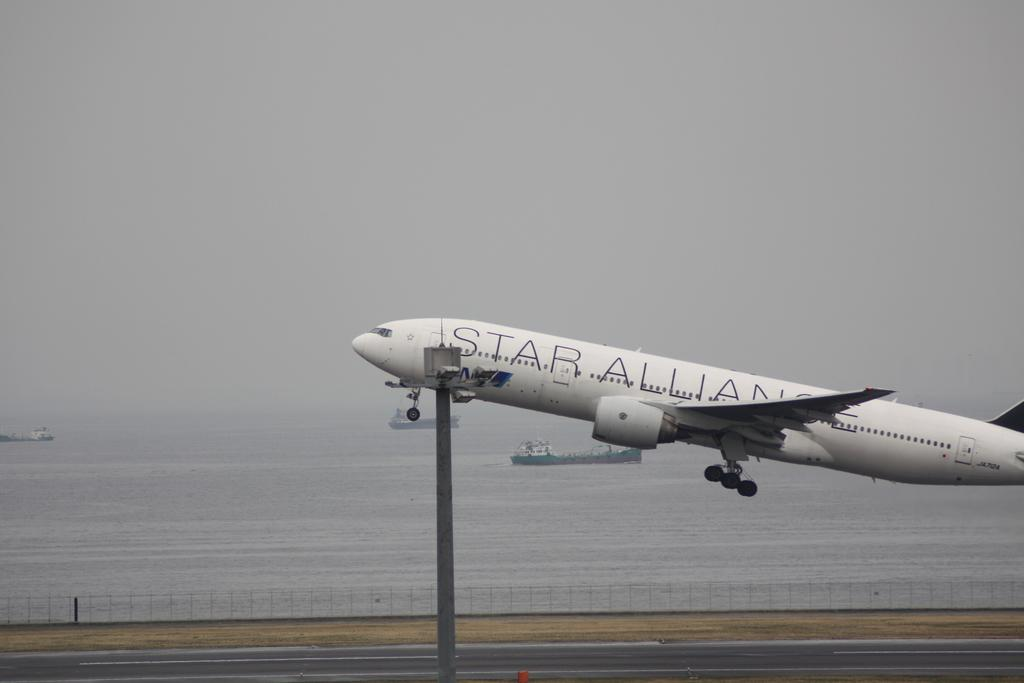<image>
Summarize the visual content of the image. A plane with the word "Star" on it during take off 